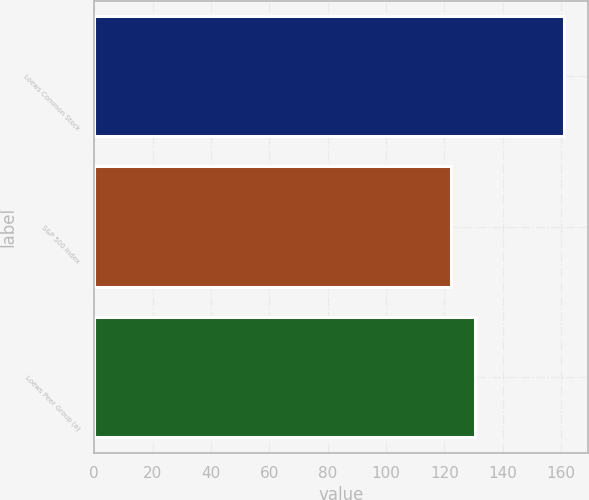<chart> <loc_0><loc_0><loc_500><loc_500><bar_chart><fcel>Loews Common Stock<fcel>S&P 500 Index<fcel>Loews Peer Group (a)<nl><fcel>161.13<fcel>122.16<fcel>130.59<nl></chart> 